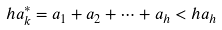<formula> <loc_0><loc_0><loc_500><loc_500>h a _ { k } ^ { * } = a _ { 1 } + a _ { 2 } + \cdots + a _ { h } < h a _ { h }</formula> 